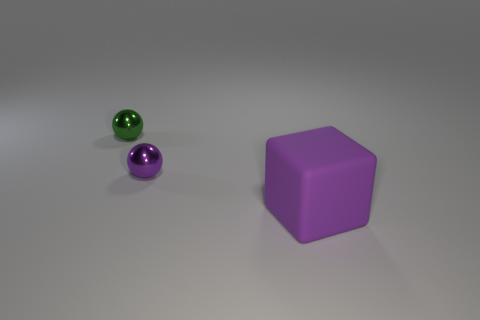What textures are visible on the surfaces in this image? The surfaces in the image have a matte finish with a hint of glossiness, most evident on the purple objects where you can see subtle light reflections. The floor has a smooth texture with some speckled noise, contributing to the overall realism of the setting. How might the texture affect the objects? The texture affects how light interacts with the objects, influencing the reflections and shadows we see. A smoother texture on the purple objects suggests they might feel sleek to the touch, while the noise on the floor might offer a slight grittiness underfoot. 